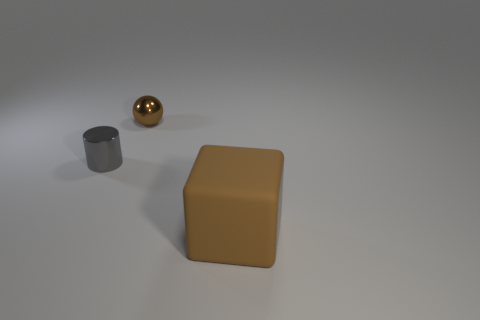Add 3 tiny blue matte objects. How many objects exist? 6 Subtract all spheres. How many objects are left? 2 Subtract all tiny metal cylinders. Subtract all large brown rubber things. How many objects are left? 1 Add 3 large rubber cubes. How many large rubber cubes are left? 4 Add 3 purple cylinders. How many purple cylinders exist? 3 Subtract 0 yellow blocks. How many objects are left? 3 